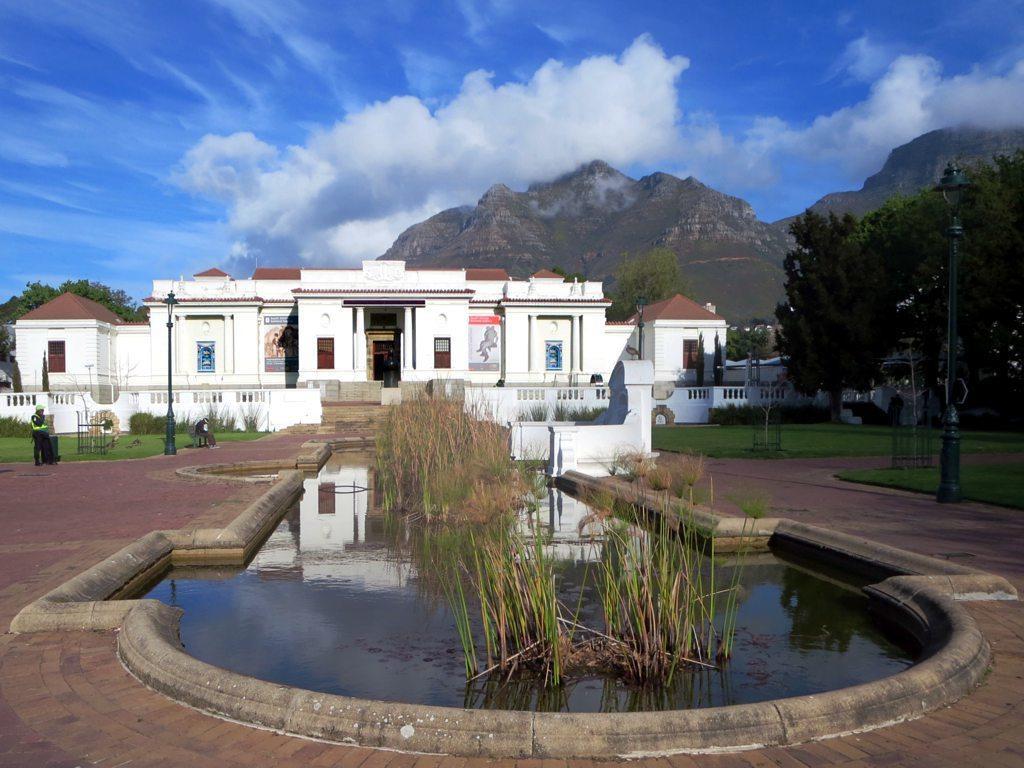In one or two sentences, can you explain what this image depicts? In this image we can see building, street poles, street lights, persons standing, grass, water, trees, hills and sky with clouds. 